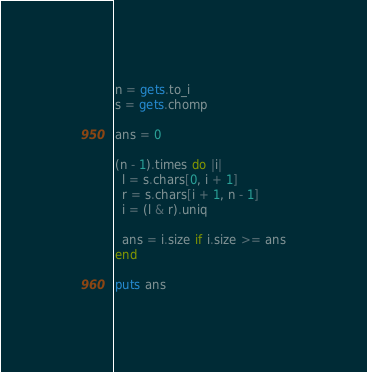<code> <loc_0><loc_0><loc_500><loc_500><_Ruby_>n = gets.to_i
s = gets.chomp

ans = 0

(n - 1).times do |i|
  l = s.chars[0, i + 1]
  r = s.chars[i + 1, n - 1]
  i = (l & r).uniq

  ans = i.size if i.size >= ans
end

puts ans
</code> 